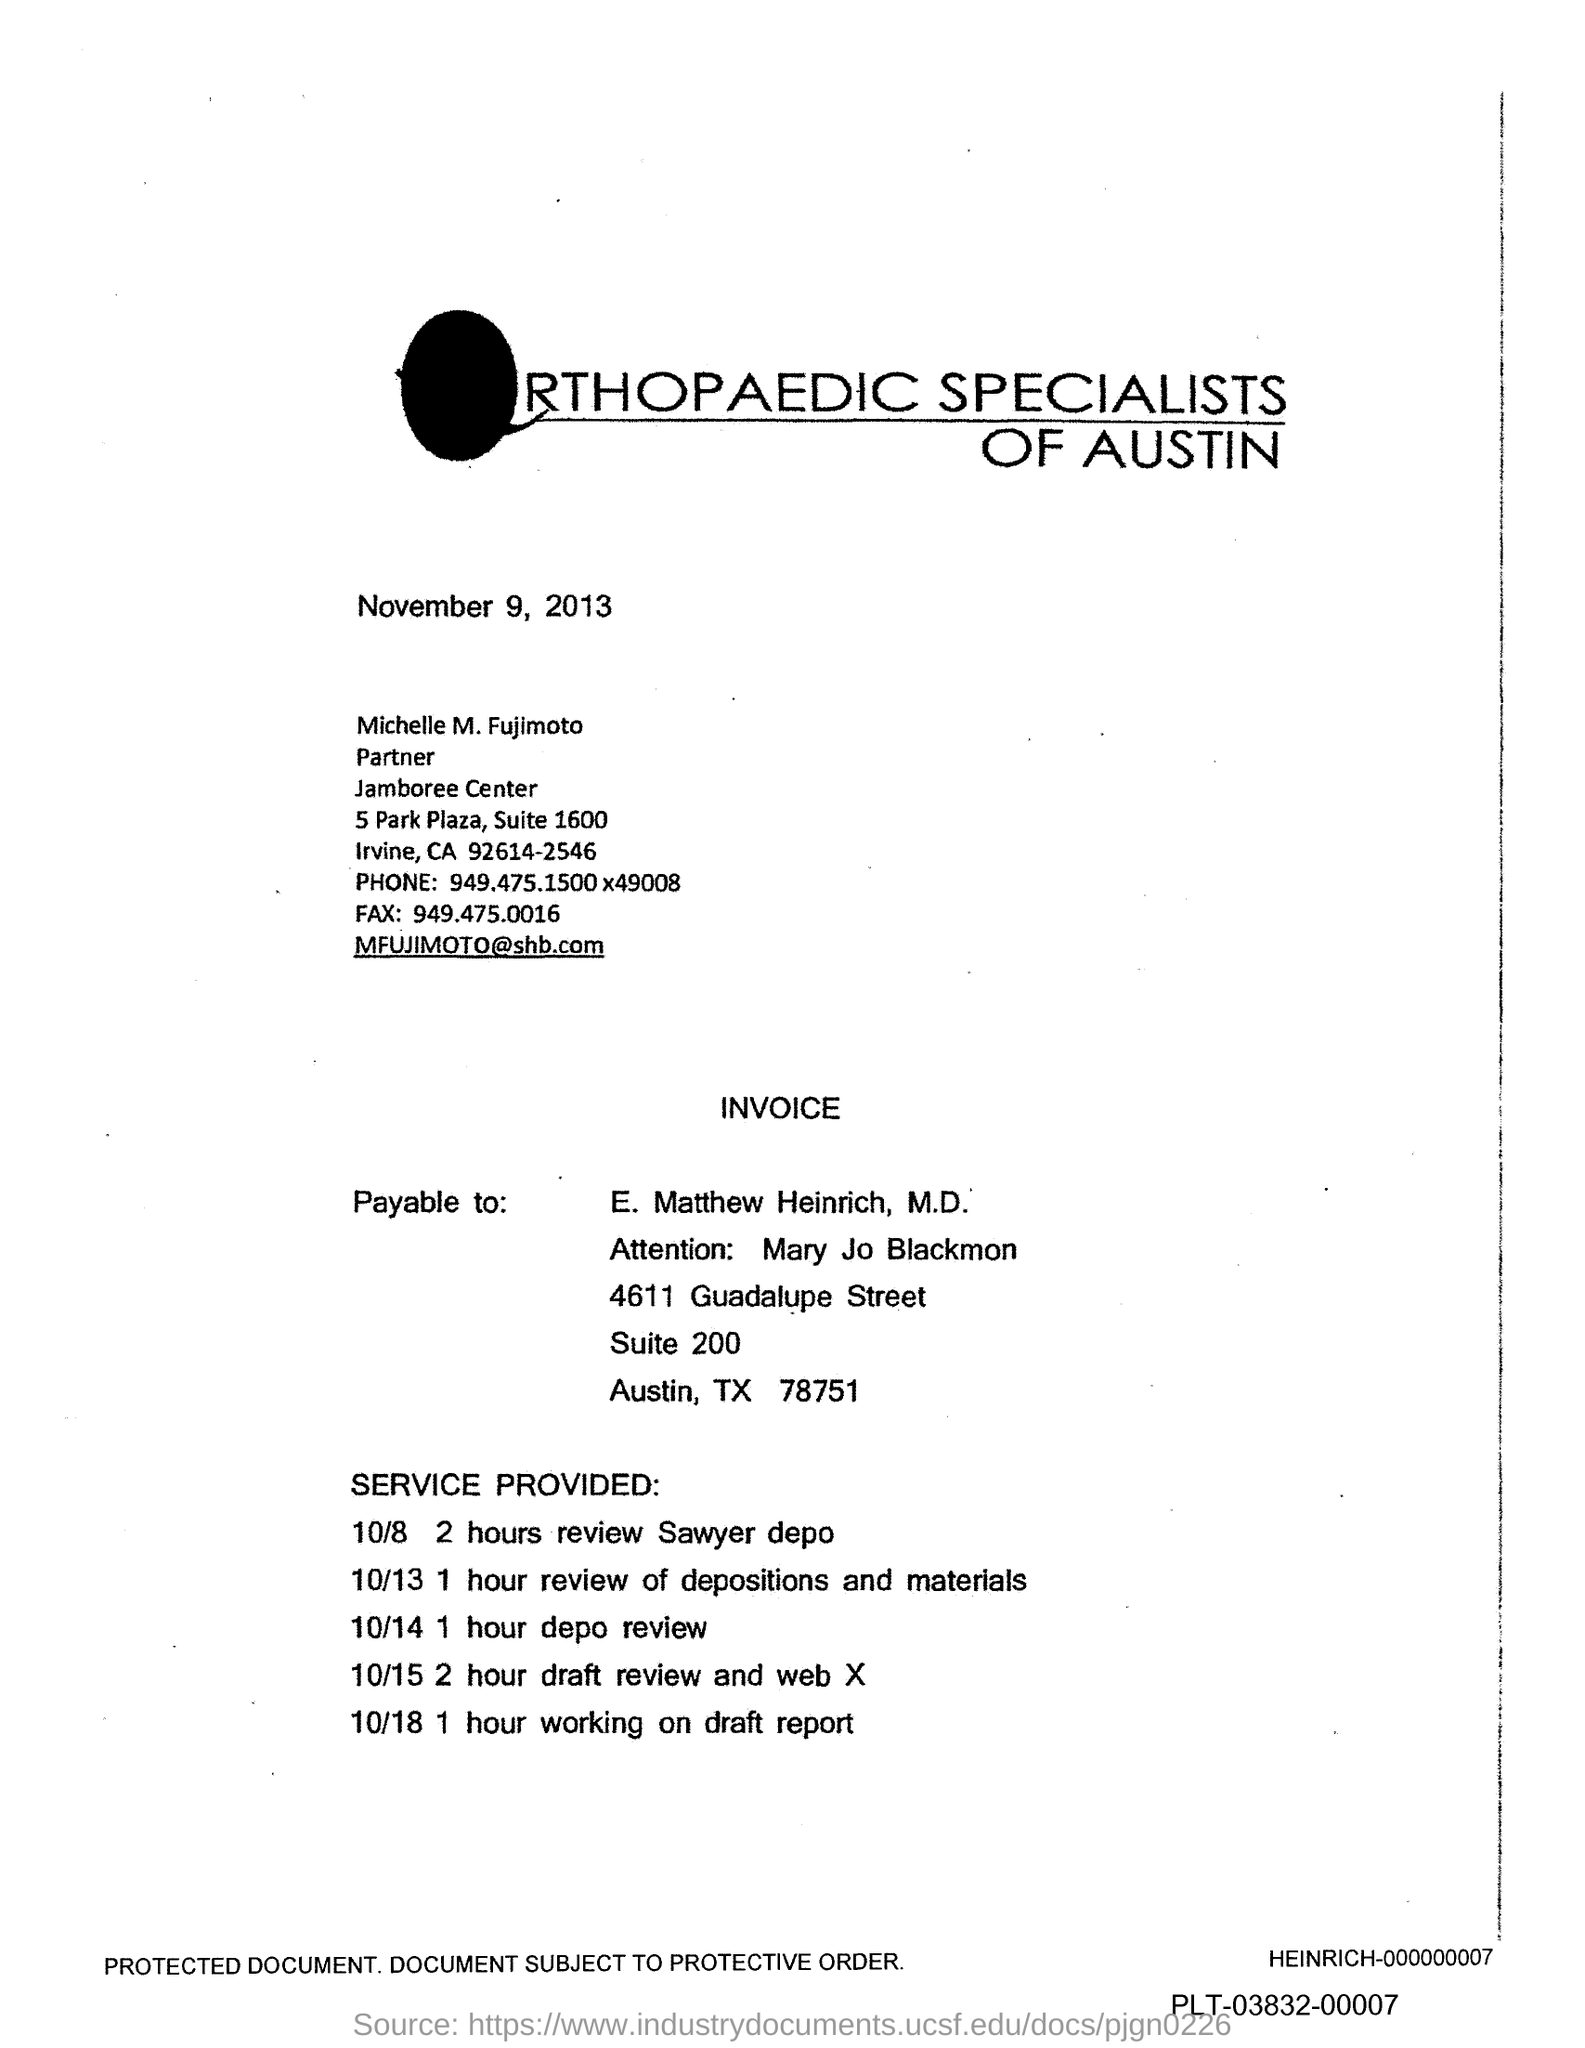What is the date on the document?
Give a very brief answer. November 9, 2013. Who is the Payable to?
Provide a succinct answer. E. Matthew Heinrich. Who is the Attention To?
Provide a short and direct response. Mary Jo Blackmon. When is the 2 hours review Sawyer depo?
Your answer should be compact. 10/8. 